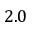Convert formula to latex. <formula><loc_0><loc_0><loc_500><loc_500>2 . 0</formula> 